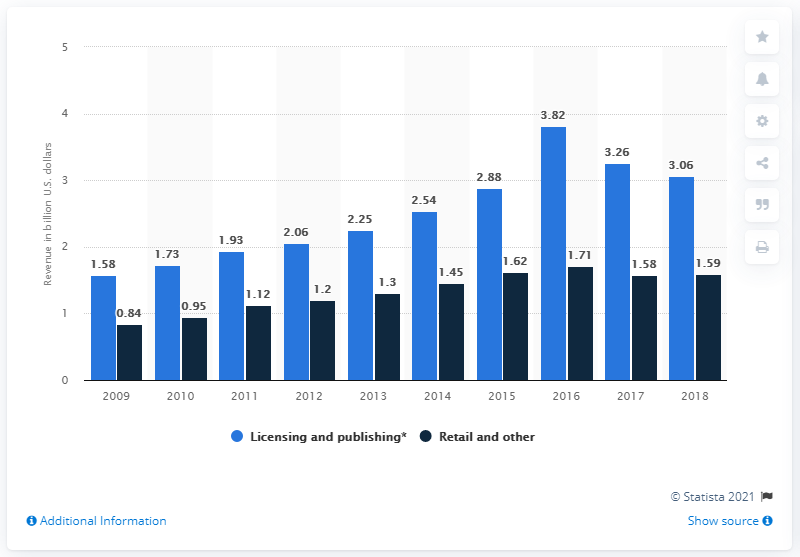Highlight a few significant elements in this photo. In 2018, licensing, publishing, and games collectively contributed 3.06% of The Walt Disney Company's total revenue. Retail sales for The Walt Disney Company in 2018 were approximately 1.59 trillion dollars. 